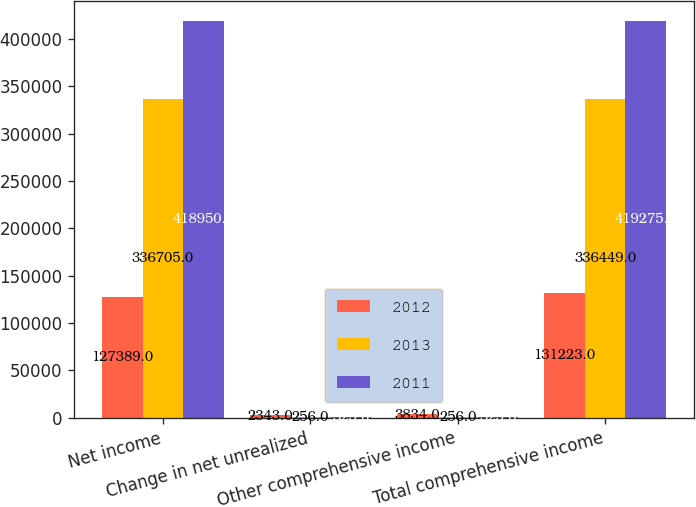Convert chart to OTSL. <chart><loc_0><loc_0><loc_500><loc_500><stacked_bar_chart><ecel><fcel>Net income<fcel>Change in net unrealized<fcel>Other comprehensive income<fcel>Total comprehensive income<nl><fcel>2012<fcel>127389<fcel>2343<fcel>3834<fcel>131223<nl><fcel>2013<fcel>336705<fcel>256<fcel>256<fcel>336449<nl><fcel>2011<fcel>418950<fcel>325<fcel>325<fcel>419275<nl></chart> 